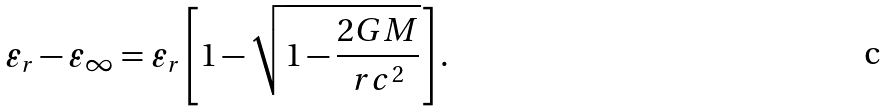<formula> <loc_0><loc_0><loc_500><loc_500>\varepsilon _ { r } - \varepsilon _ { \infty } = \varepsilon _ { r } \left [ 1 - \sqrt { 1 - \frac { 2 G M } { r c ^ { 2 } } } \right ] .</formula> 